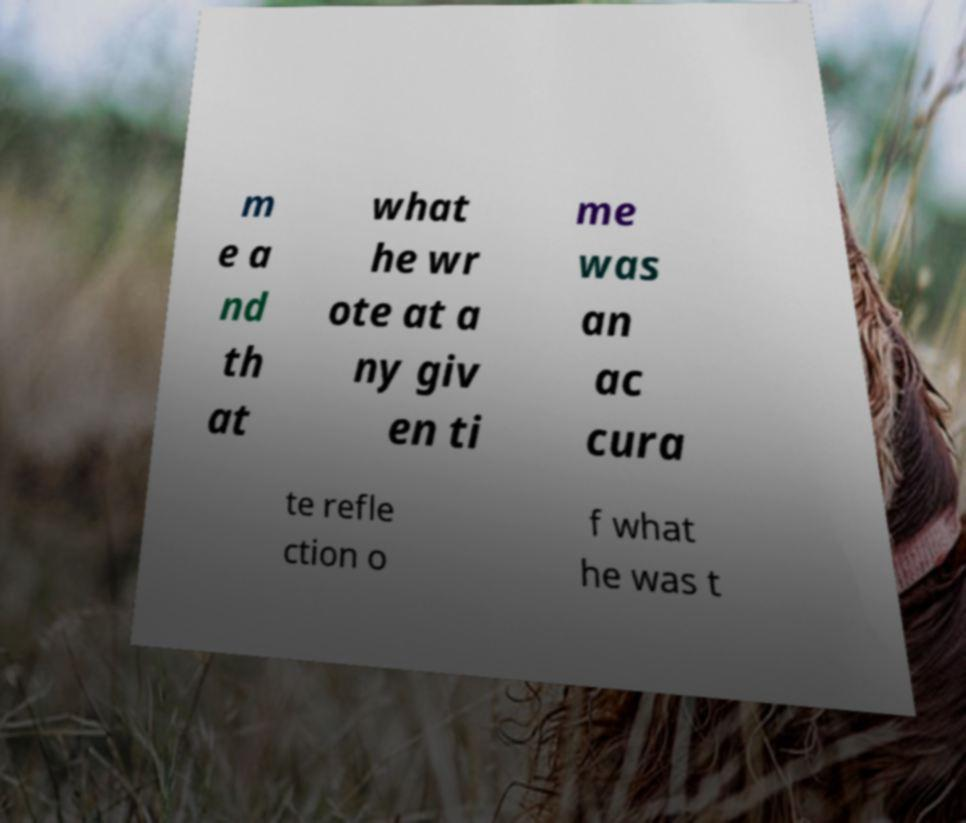Can you accurately transcribe the text from the provided image for me? m e a nd th at what he wr ote at a ny giv en ti me was an ac cura te refle ction o f what he was t 